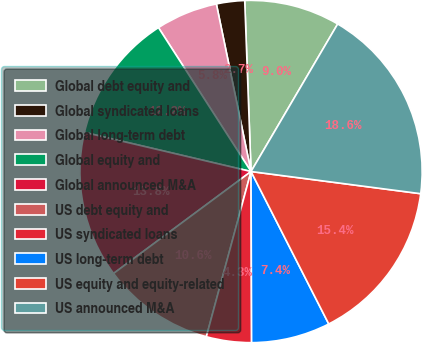Convert chart. <chart><loc_0><loc_0><loc_500><loc_500><pie_chart><fcel>Global debt equity and<fcel>Global syndicated loans<fcel>Global long-term debt<fcel>Global equity and<fcel>Global announced M&A<fcel>US debt equity and<fcel>US syndicated loans<fcel>US long-term debt<fcel>US equity and equity-related<fcel>US announced M&A<nl><fcel>9.04%<fcel>2.66%<fcel>5.85%<fcel>12.23%<fcel>13.83%<fcel>10.64%<fcel>4.26%<fcel>7.45%<fcel>15.43%<fcel>18.62%<nl></chart> 